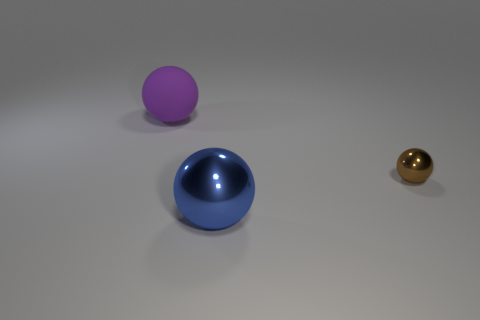How would you describe the material of the surface on which the spheres are placed? The surface appears to be a flat, matte textured material with a mild reflection, suggesting that it could be made of a non-glossy plastic or coated metal. 